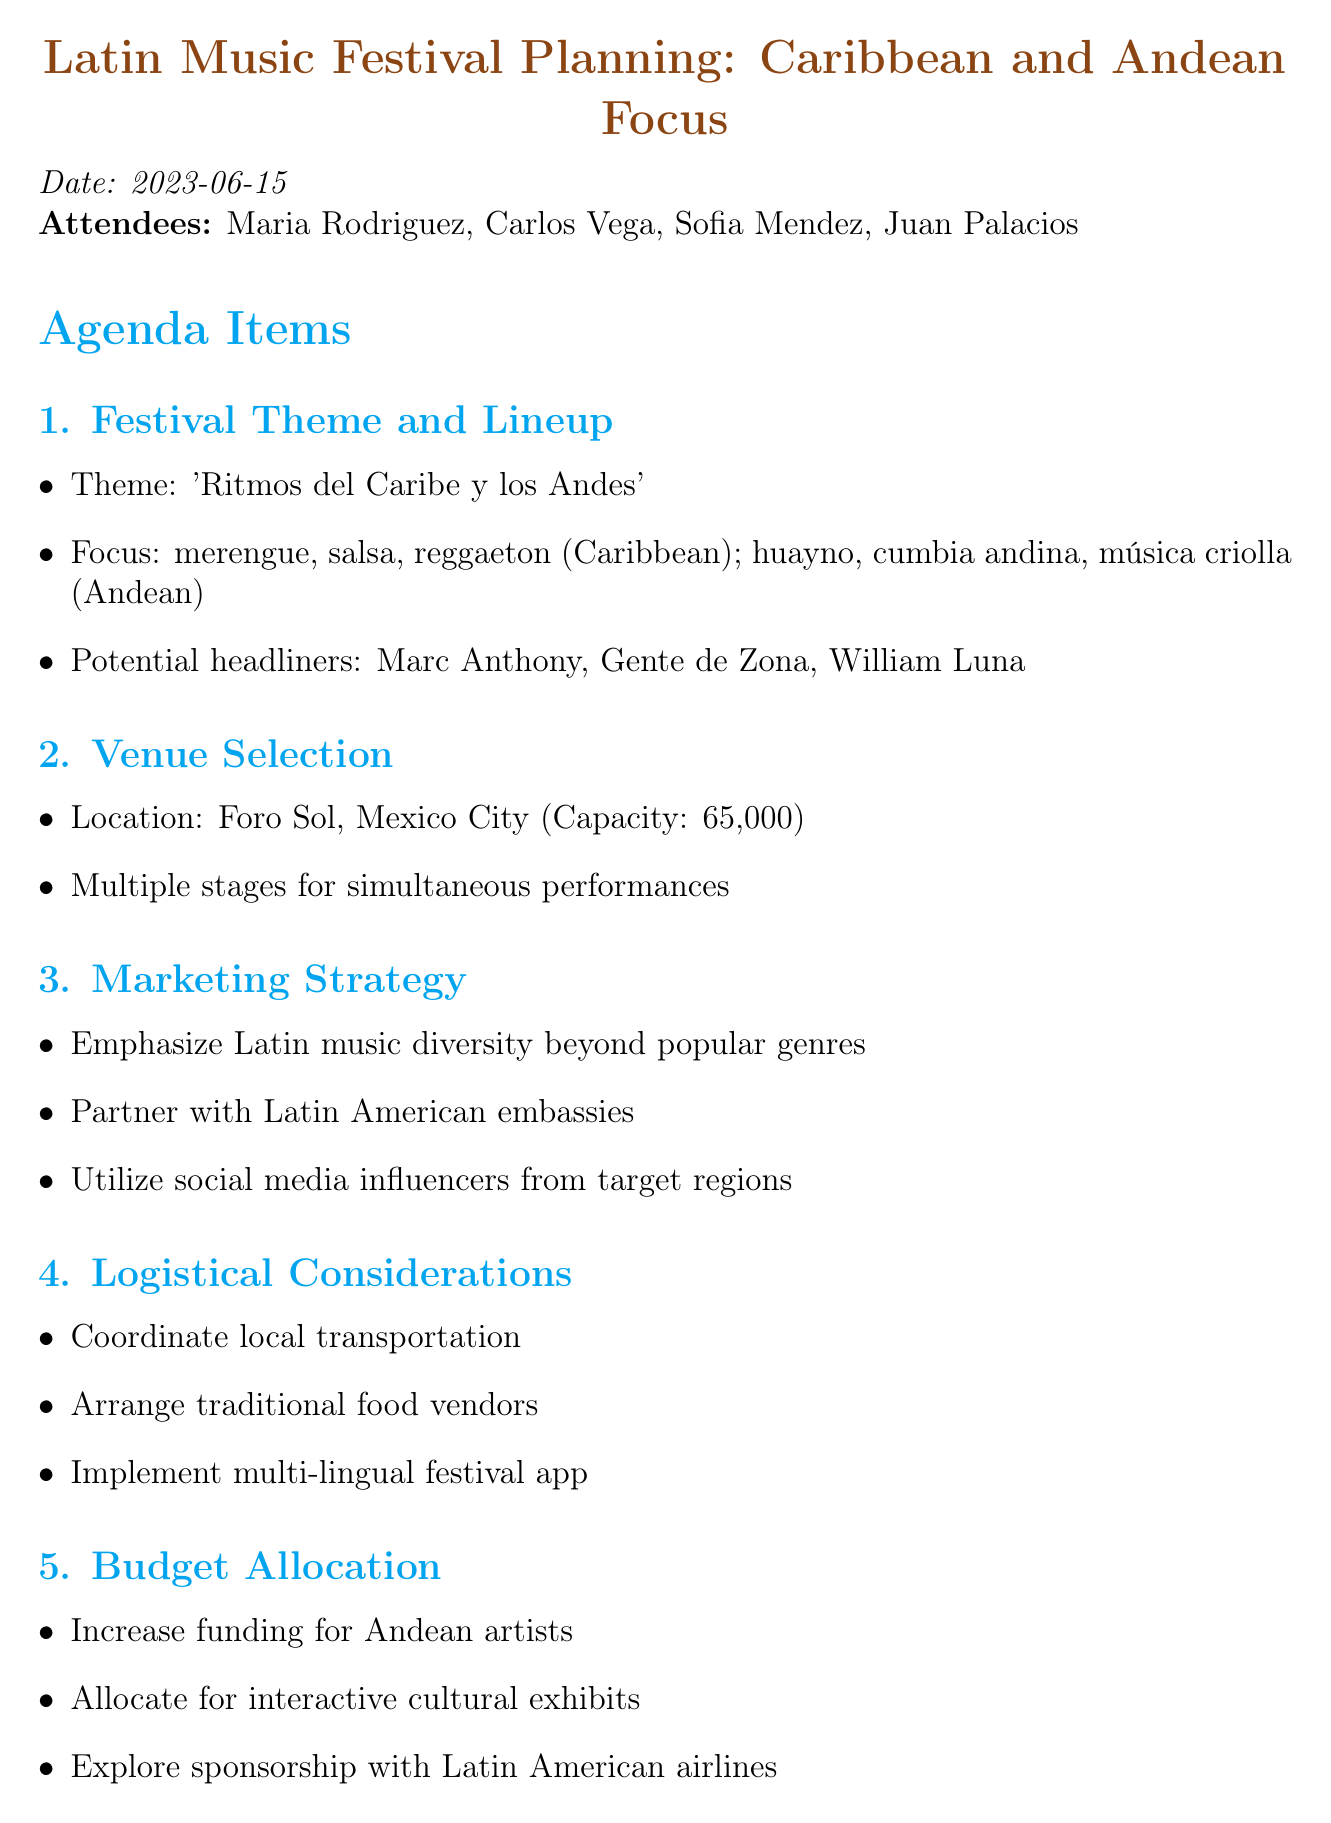what is the proposed theme of the festival? The proposed theme is mentioned in the document as 'Ritmos del Caribe y los Andes'.
Answer: 'Ritmos del Caribe y los Andes' who is responsible for finalizing the artist lineup? The action item specifies that Carlos is to finalize the artist lineup.
Answer: Carlos what is the capacity of the recommended venue? The document states the venue's capacity as 65,000 attendees.
Answer: 65,000 which Caribbean styles are highlighted in the festival? The document lists merengue, salsa, and reggaeton as the Caribbean styles.
Answer: merengue, salsa, reggaeton how many action items are listed in the document? The number of action items is determined by counting the items in the list, which totals four.
Answer: four what marketing strategy involves partnering with specific organizations? The strategy involves partnering with Latin American embassies for cultural promotion.
Answer: Latin American embassies what cultural element is suggested to be incorporated into the festival? The notes suggest considering workshops on traditional instruments and dance styles.
Answer: workshops on traditional instruments and dance styles which artists are mentioned as potential headliners? The document lists Marc Anthony, Gente de Zona, and William Luna as potential headliners.
Answer: Marc Anthony, Gente de Zona, William Luna what is the focus for Andean representation? The focus on Andean representation includes huayno, cumbia andina, and música criolla.
Answer: huayno, cumbia andina, música criolla 